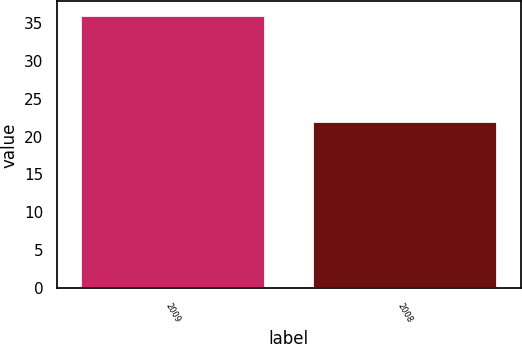Convert chart to OTSL. <chart><loc_0><loc_0><loc_500><loc_500><bar_chart><fcel>2009<fcel>2008<nl><fcel>36<fcel>22<nl></chart> 